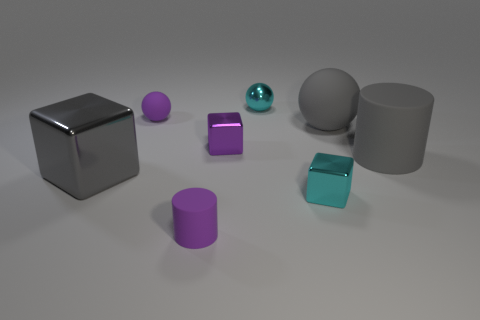Are there any other things that have the same size as the purple sphere?
Offer a very short reply. Yes. Is the number of matte objects that are to the left of the gray shiny block greater than the number of tiny cyan balls behind the cyan shiny sphere?
Your answer should be very brief. No. There is a rubber sphere left of the cyan metal ball; does it have the same size as the purple cube?
Provide a succinct answer. Yes. There is a tiny metallic block in front of the small metallic object that is to the left of the small shiny sphere; how many cyan metal things are behind it?
Your answer should be very brief. 1. What size is the sphere that is both to the right of the small matte ball and in front of the cyan ball?
Offer a very short reply. Large. What number of other things are the same shape as the big gray metallic thing?
Ensure brevity in your answer.  2. What number of small cyan metal things are on the right side of the big gray metal block?
Make the answer very short. 2. Are there fewer big matte balls that are behind the small cyan metal ball than gray rubber cylinders that are to the right of the gray rubber cylinder?
Give a very brief answer. No. The metallic thing that is to the left of the small matte thing that is behind the purple rubber thing in front of the gray sphere is what shape?
Your answer should be compact. Cube. There is a matte thing that is both behind the tiny purple cylinder and left of the big rubber sphere; what shape is it?
Make the answer very short. Sphere. 